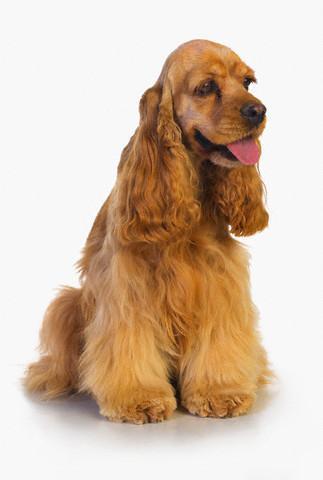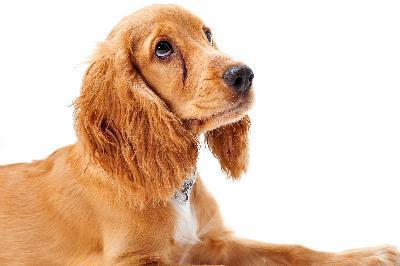The first image is the image on the left, the second image is the image on the right. Considering the images on both sides, is "A dog has its tongue sticking out." valid? Answer yes or no. Yes. The first image is the image on the left, the second image is the image on the right. Evaluate the accuracy of this statement regarding the images: "The dog in the image on the right is sitting down". Is it true? Answer yes or no. No. 